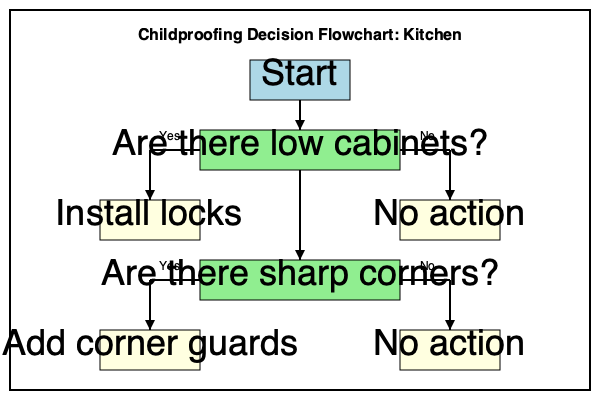Based on the flowchart for childproofing a kitchen, what is the total number of possible outcomes (end states) in this decision-making process? To determine the total number of possible outcomes in this decision-making process, we need to follow the flowchart and count the number of end states. Let's break it down step-by-step:

1. The flowchart starts with the question "Are there low cabinets?"
   - If Yes, it leads to "Install locks"
   - If No, it leads to "No action"

2. Regardless of the answer to the first question, the flowchart continues to the next question: "Are there sharp corners?"
   - If Yes, it leads to "Add corner guards"
   - If No, it leads to "No action"

3. Now, let's consider all possible paths:
   a) Low cabinets (Yes) -> Install locks -> Sharp corners (Yes) -> Add corner guards
   b) Low cabinets (Yes) -> Install locks -> Sharp corners (No) -> No action
   c) Low cabinets (No) -> No action -> Sharp corners (Yes) -> Add corner guards
   d) Low cabinets (No) -> No action -> Sharp corners (No) -> No action

4. Count the unique end states:
   - Install locks and Add corner guards
   - Install locks and No action
   - No action and Add corner guards
   - No action (for both questions)

Therefore, there are 4 possible outcomes (end states) in this decision-making process for childproofing a kitchen.
Answer: 4 